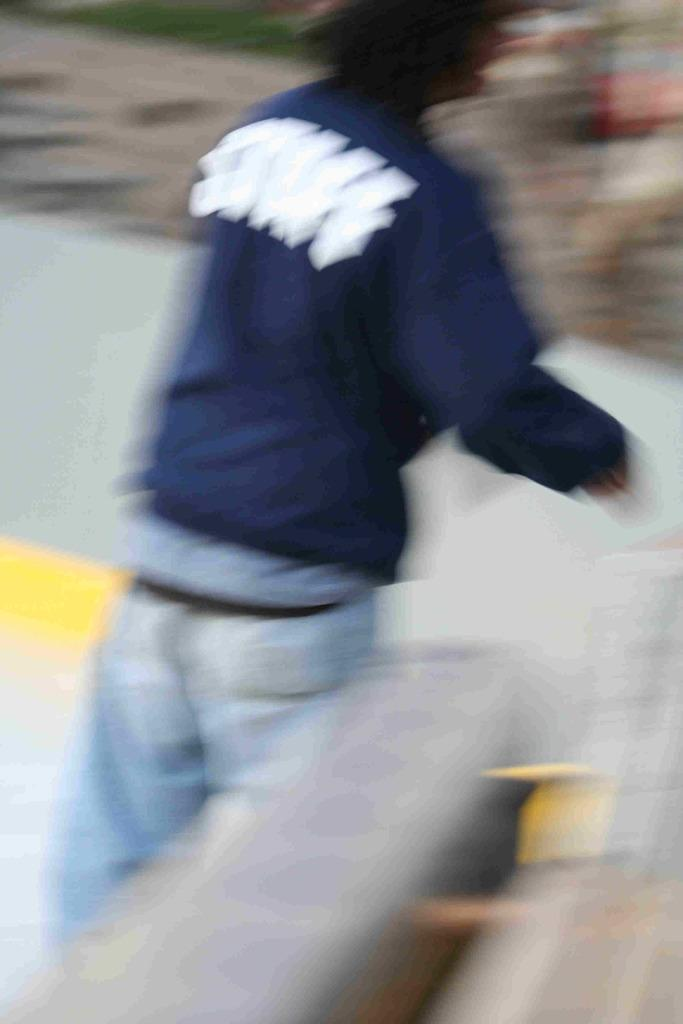What is the main subject of the image? There is a person standing in the image. Can you describe the background of the image? The background of the image is blurry. What type of ring is the person wearing on their finger in the image? There is no ring visible on the person's finger in the image. 